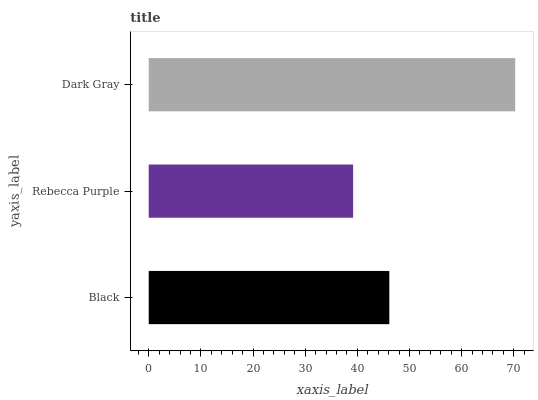Is Rebecca Purple the minimum?
Answer yes or no. Yes. Is Dark Gray the maximum?
Answer yes or no. Yes. Is Dark Gray the minimum?
Answer yes or no. No. Is Rebecca Purple the maximum?
Answer yes or no. No. Is Dark Gray greater than Rebecca Purple?
Answer yes or no. Yes. Is Rebecca Purple less than Dark Gray?
Answer yes or no. Yes. Is Rebecca Purple greater than Dark Gray?
Answer yes or no. No. Is Dark Gray less than Rebecca Purple?
Answer yes or no. No. Is Black the high median?
Answer yes or no. Yes. Is Black the low median?
Answer yes or no. Yes. Is Dark Gray the high median?
Answer yes or no. No. Is Dark Gray the low median?
Answer yes or no. No. 